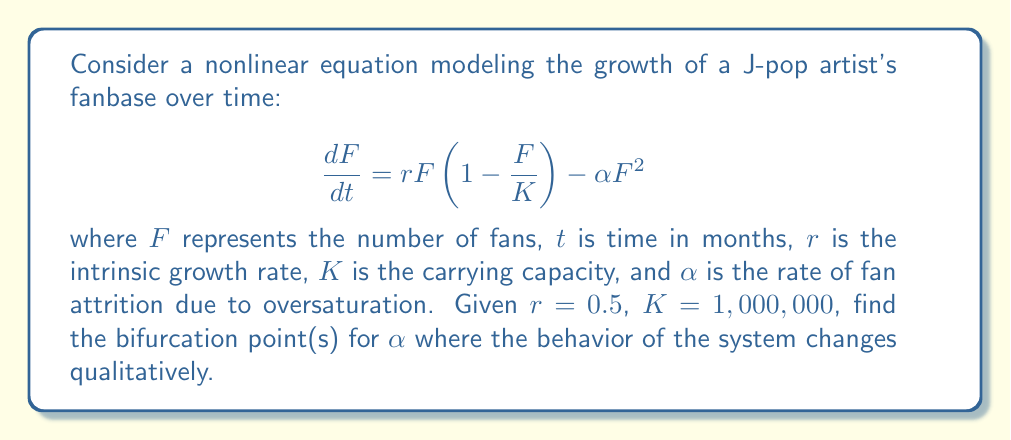Could you help me with this problem? To find the bifurcation points, we need to follow these steps:

1) First, find the equilibrium points by setting $\frac{dF}{dt} = 0$:

   $$ 0 = rF(1 - \frac{F}{K}) - \alpha F^2 $$

2) Factoring out $F$:

   $$ 0 = F(r(1 - \frac{F}{K}) - \alpha F) $$

3) We get two equilibrium points:
   
   $F_1 = 0$ and $F_2 = \frac{r}{\alpha} - \frac{r}{K\alpha}$

4) The non-zero equilibrium point $F_2$ exists only when $\frac{r}{\alpha} - \frac{r}{K\alpha} > 0$

5) This condition can be rewritten as:

   $$ \frac{r}{\alpha} > \frac{r}{K\alpha} $$
   $$ K > 1 $$

   Which is always true for our given $K = 1,000,000$

6) The stability of $F_2$ changes when:

   $$ \frac{r}{\alpha} - \frac{r}{K\alpha} = K $$

7) Solving this equation:

   $$ \frac{r}{\alpha} - K = \frac{r}{K\alpha} $$
   $$ K^2\alpha = r - K\alpha $$
   $$ K^2\alpha + K\alpha = r $$
   $$ \alpha(K^2 + K) = r $$
   $$ \alpha = \frac{r}{K^2 + K} $$

8) Substituting the given values:

   $$ \alpha = \frac{0.5}{1,000,000^2 + 1,000,000} \approx 5 \times 10^{-13} $$

This value of $\alpha$ is the bifurcation point where the stability of the non-zero equilibrium changes.
Answer: $\alpha \approx 5 \times 10^{-13}$ 